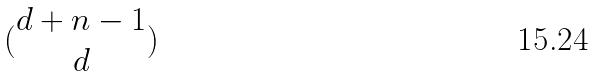Convert formula to latex. <formula><loc_0><loc_0><loc_500><loc_500>( \begin{matrix} d + n - 1 \\ d \end{matrix} )</formula> 